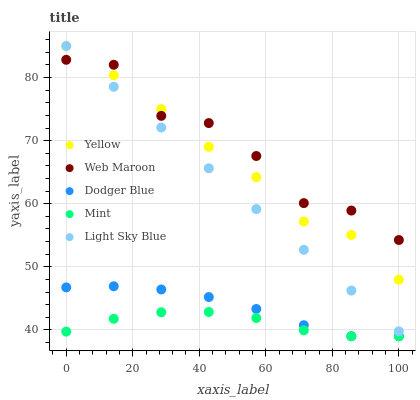Does Mint have the minimum area under the curve?
Answer yes or no. Yes. Does Web Maroon have the maximum area under the curve?
Answer yes or no. Yes. Does Light Sky Blue have the minimum area under the curve?
Answer yes or no. No. Does Light Sky Blue have the maximum area under the curve?
Answer yes or no. No. Is Light Sky Blue the smoothest?
Answer yes or no. Yes. Is Web Maroon the roughest?
Answer yes or no. Yes. Is Web Maroon the smoothest?
Answer yes or no. No. Is Light Sky Blue the roughest?
Answer yes or no. No. Does Dodger Blue have the lowest value?
Answer yes or no. Yes. Does Light Sky Blue have the lowest value?
Answer yes or no. No. Does Yellow have the highest value?
Answer yes or no. Yes. Does Web Maroon have the highest value?
Answer yes or no. No. Is Dodger Blue less than Light Sky Blue?
Answer yes or no. Yes. Is Yellow greater than Mint?
Answer yes or no. Yes. Does Dodger Blue intersect Mint?
Answer yes or no. Yes. Is Dodger Blue less than Mint?
Answer yes or no. No. Is Dodger Blue greater than Mint?
Answer yes or no. No. Does Dodger Blue intersect Light Sky Blue?
Answer yes or no. No. 